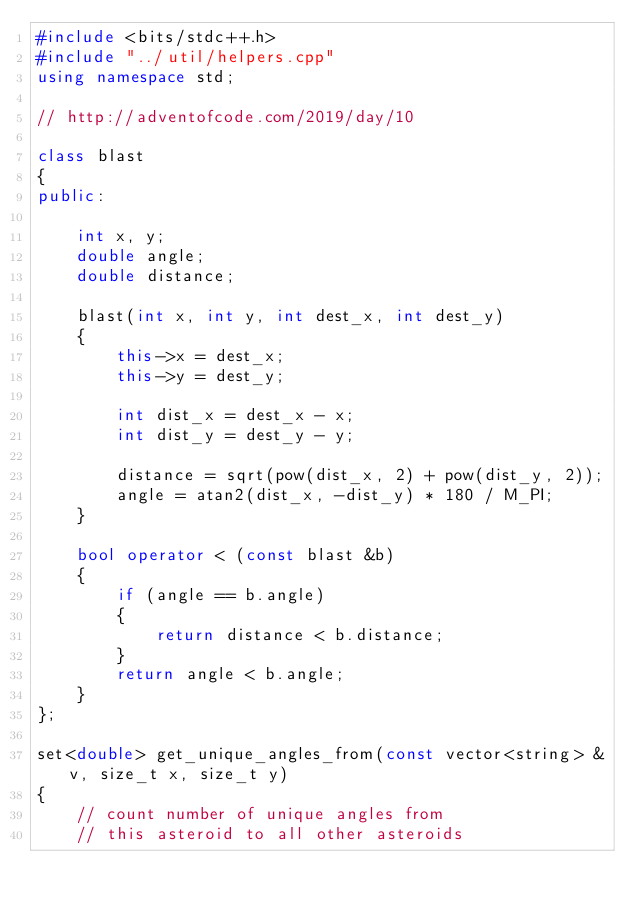<code> <loc_0><loc_0><loc_500><loc_500><_C++_>#include <bits/stdc++.h>
#include "../util/helpers.cpp"
using namespace std;

// http://adventofcode.com/2019/day/10

class blast
{
public:

	int x, y;
	double angle;
	double distance;

	blast(int x, int y, int dest_x, int dest_y)
	{
		this->x = dest_x;
		this->y = dest_y;

		int dist_x = dest_x - x;
		int dist_y = dest_y - y;

		distance = sqrt(pow(dist_x, 2) + pow(dist_y, 2));
		angle = atan2(dist_x, -dist_y) * 180 / M_PI;
	}

	bool operator < (const blast &b)
	{
		if (angle == b.angle)
		{
			return distance < b.distance;
		}
		return angle < b.angle;
	}
};

set<double> get_unique_angles_from(const vector<string> &v, size_t x, size_t y)
{
	// count number of unique angles from
	// this asteroid to all other asteroids</code> 